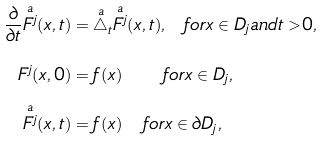Convert formula to latex. <formula><loc_0><loc_0><loc_500><loc_500>\frac { \partial } { \partial t } \overset { a } { F ^ { j } } ( x , t ) & = \overset { a } { \triangle } _ { t } \overset { a } { F ^ { j } } ( x , t ) , \ \ f o r x \in D _ { j } a n d t > 0 , \\ F ^ { j } ( x , 0 ) & = f ( x ) \ \ \ \ \ f o r x \in D _ { j } , \\ \overset { a } { F ^ { j } } ( x , t ) & = f ( x ) \quad f o r x \in \partial D _ { j } ,</formula> 